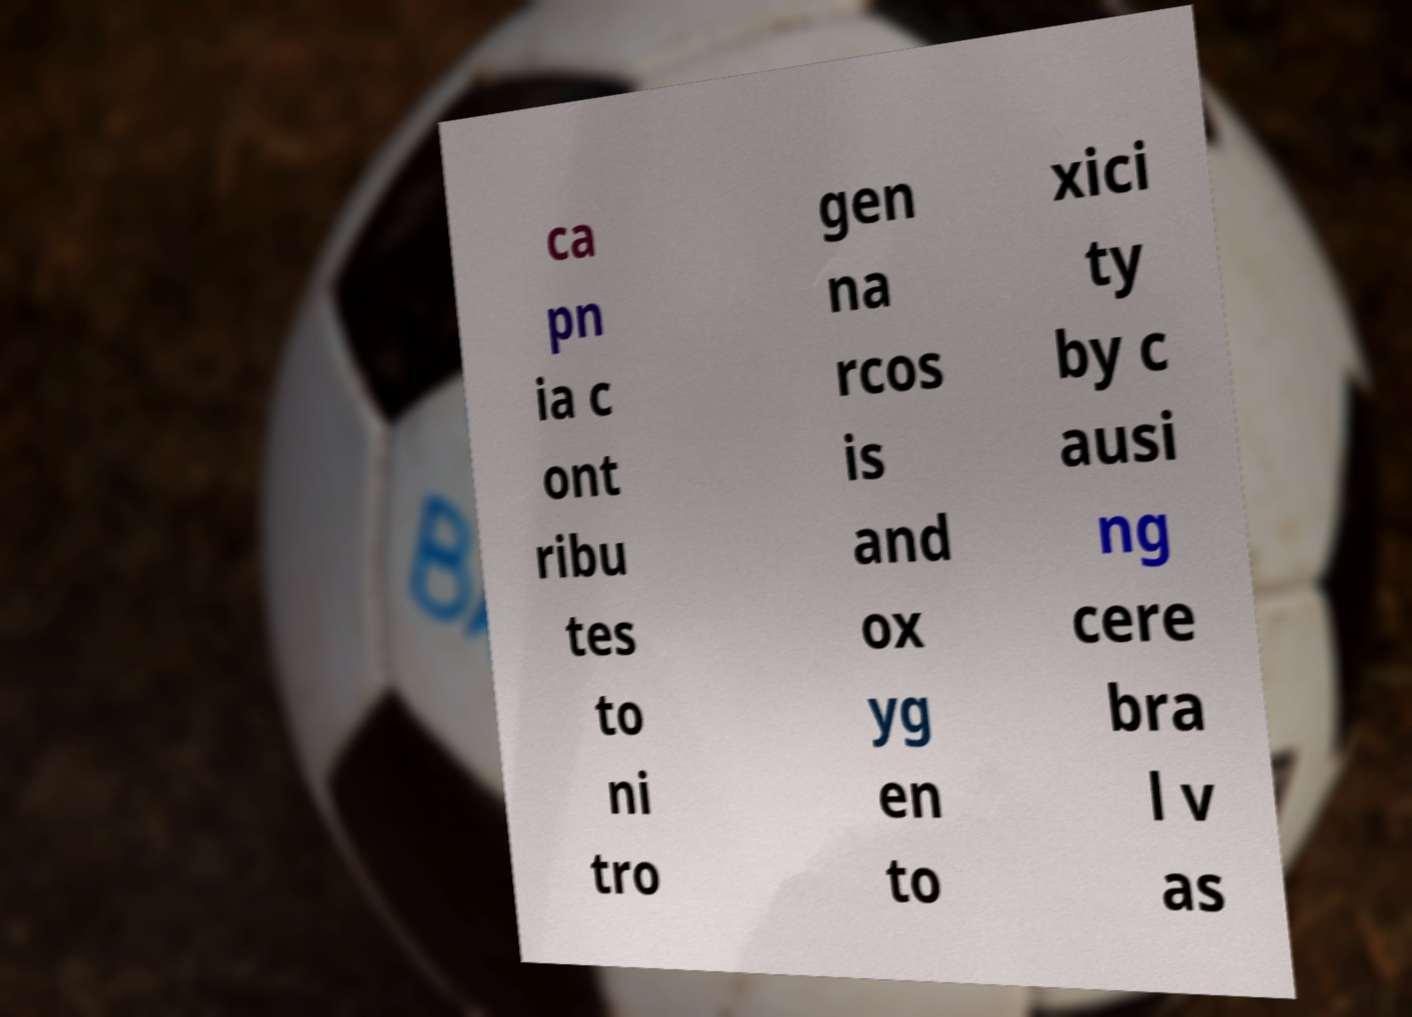There's text embedded in this image that I need extracted. Can you transcribe it verbatim? ca pn ia c ont ribu tes to ni tro gen na rcos is and ox yg en to xici ty by c ausi ng cere bra l v as 